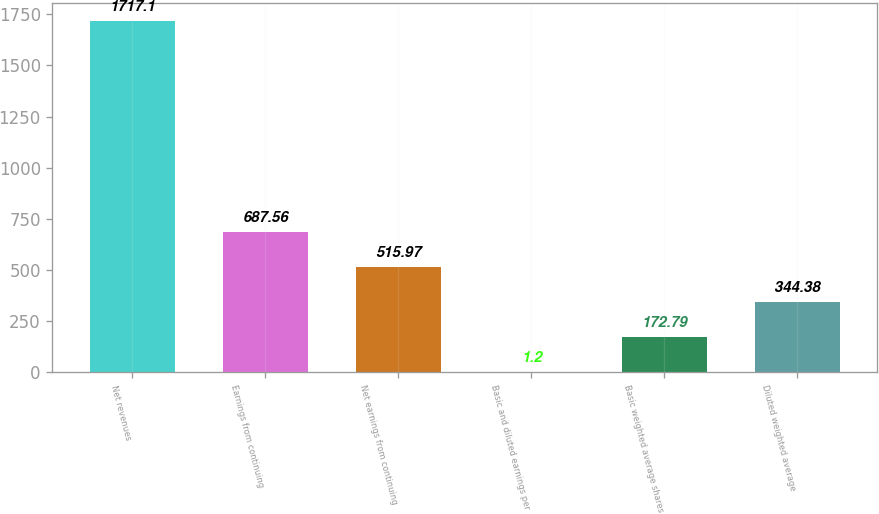Convert chart. <chart><loc_0><loc_0><loc_500><loc_500><bar_chart><fcel>Net revenues<fcel>Earnings from continuing<fcel>Net earnings from continuing<fcel>Basic and diluted earnings per<fcel>Basic weighted average shares<fcel>Diluted weighted average<nl><fcel>1717.1<fcel>687.56<fcel>515.97<fcel>1.2<fcel>172.79<fcel>344.38<nl></chart> 